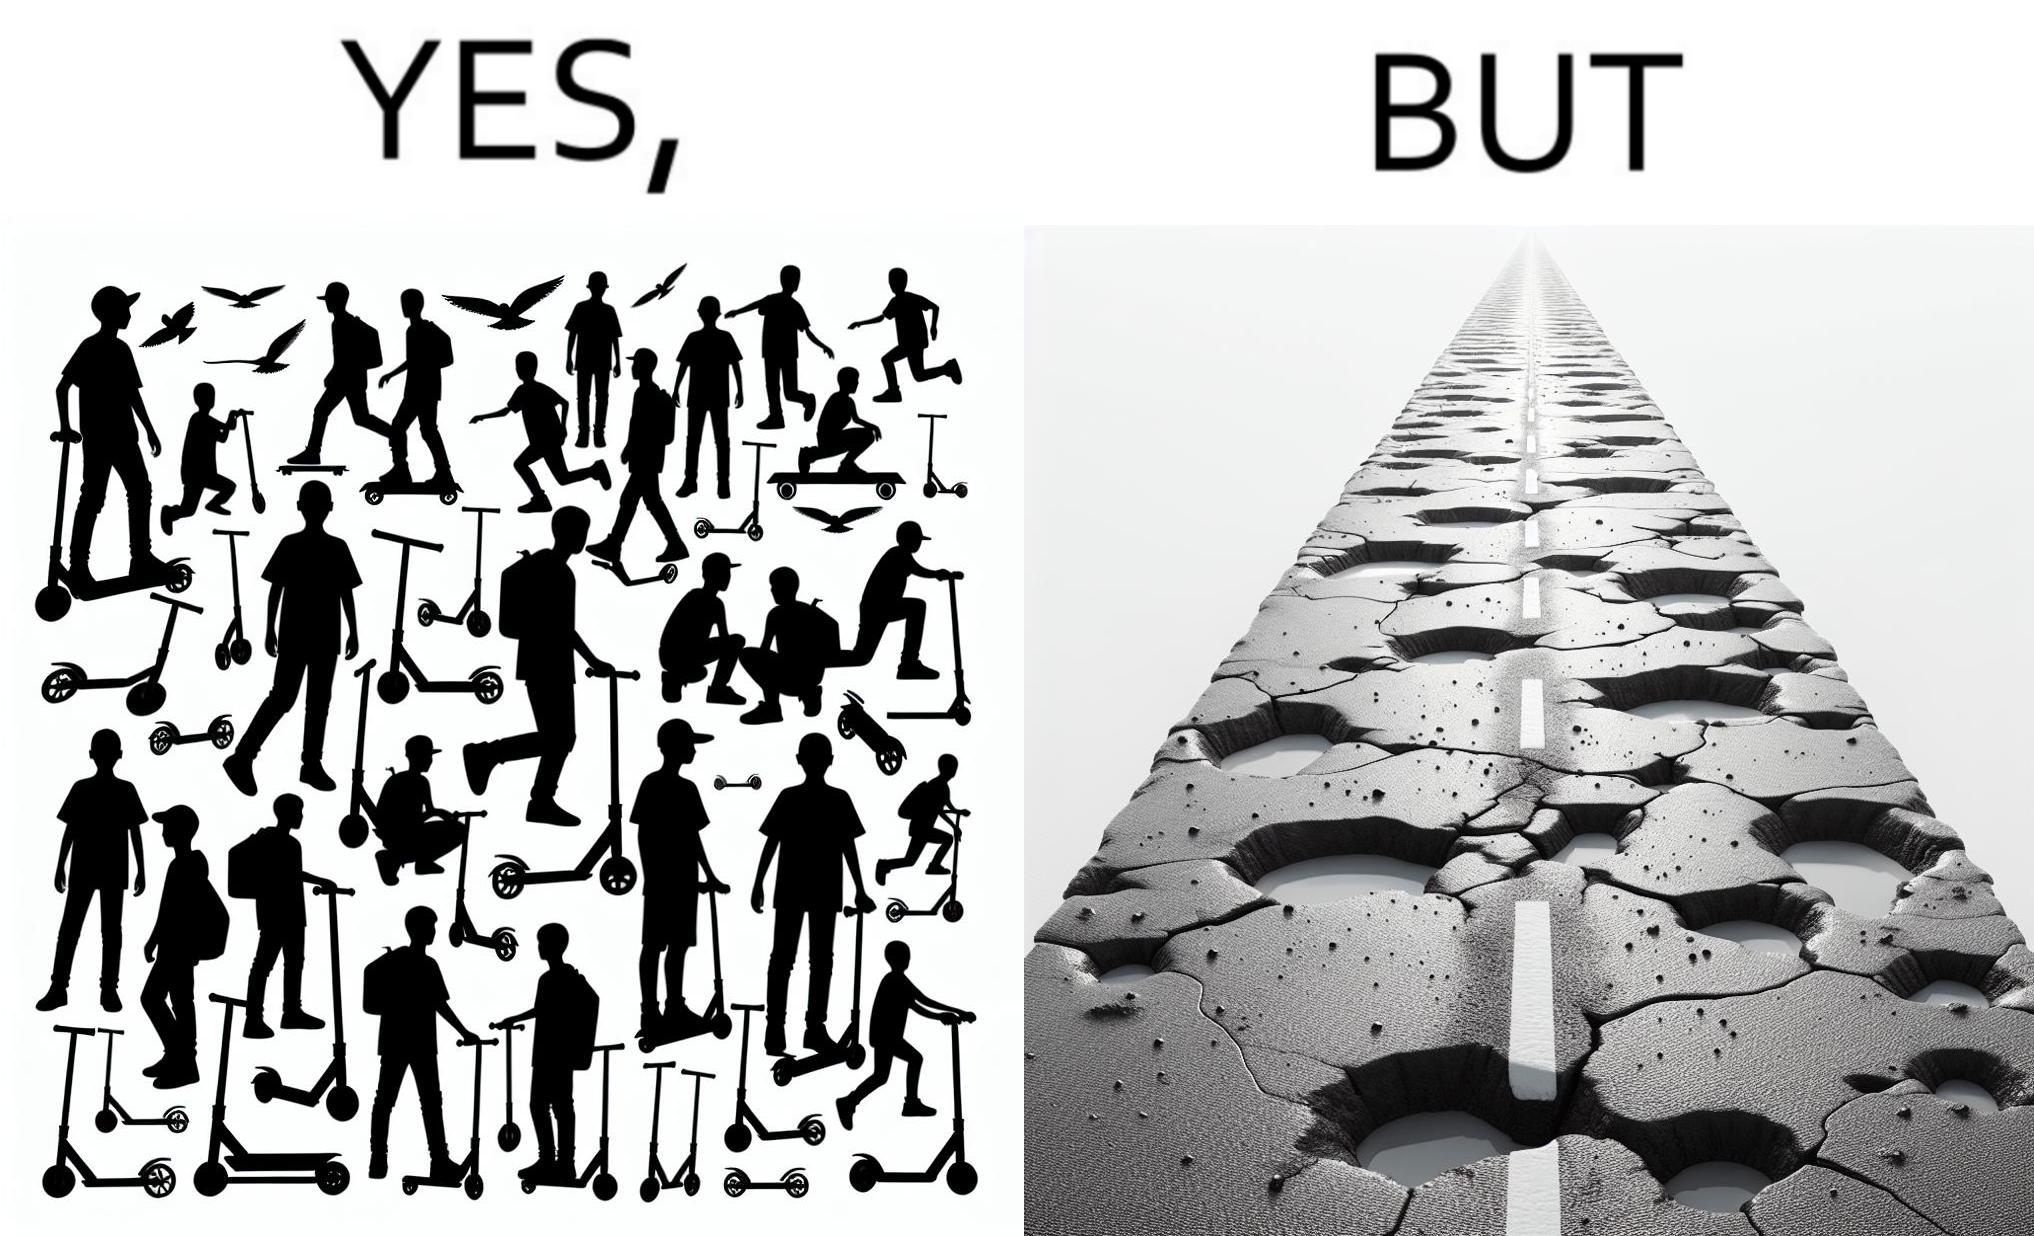Is this image satirical or non-satirical? Yes, this image is satirical. 